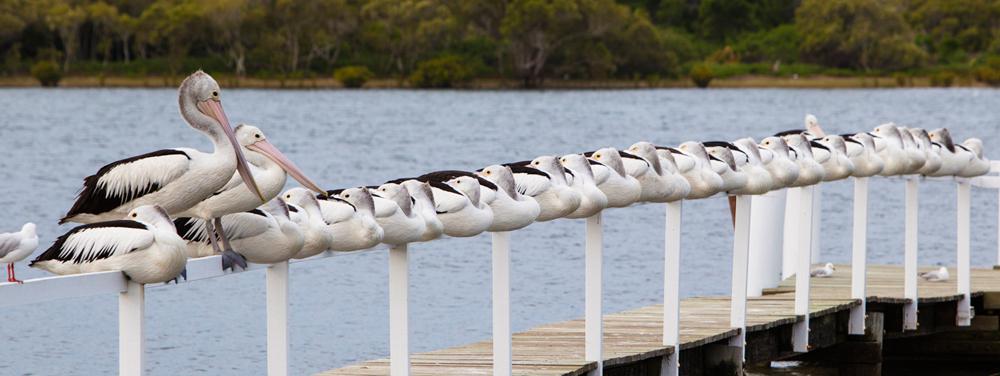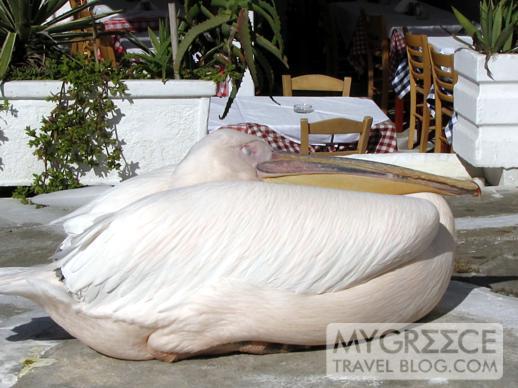The first image is the image on the left, the second image is the image on the right. Examine the images to the left and right. Is the description "One image shows a single white bird tucked into an egg shape, and the other shows a group of black-and-white birds with necks tucked backward." accurate? Answer yes or no. Yes. The first image is the image on the left, the second image is the image on the right. Given the left and right images, does the statement "One image shows one non-standing white pelican, and the other image shows multiple black and white pelicans." hold true? Answer yes or no. Yes. The first image is the image on the left, the second image is the image on the right. Considering the images on both sides, is "There's no more than two birds." valid? Answer yes or no. No. The first image is the image on the left, the second image is the image on the right. Assess this claim about the two images: "The left image contains no more than one bird.". Correct or not? Answer yes or no. No. 